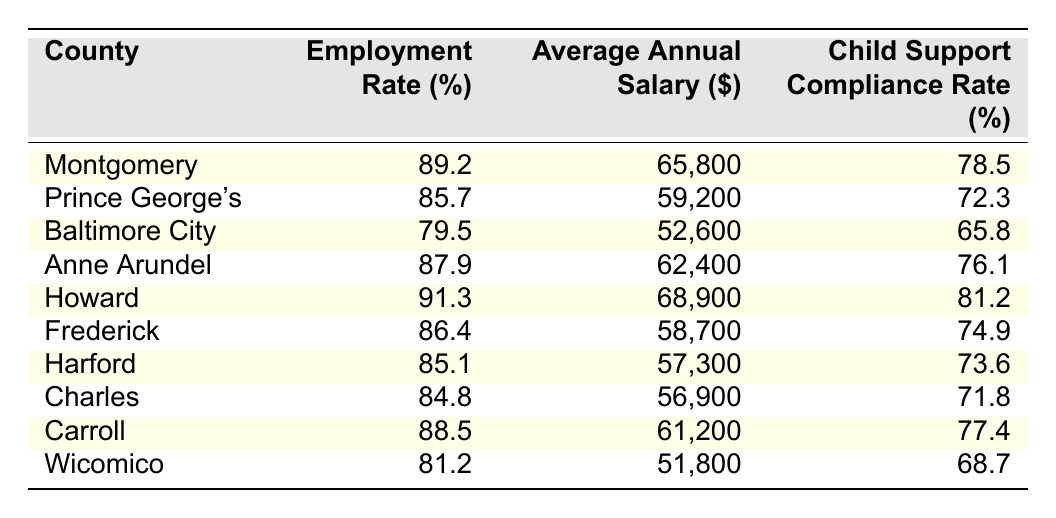What is the employment rate in Howard County? The table shows that the employment rate in Howard County is directly listed as 91.3%.
Answer: 91.3% Which county has the highest average annual salary? By examining the "Average Annual Salary" column, Howard County has the highest salary at $68,900.
Answer: Howard County What is the average employment rate of all the counties listed? The employment rates are 89.2, 85.7, 79.5, 87.9, 91.3, 86.4, 85.1, 84.8, 88.5, and 81.2. Adding these gives a total of 870.2, then dividing by 10 counties gives an average of 87.02%.
Answer: 87.02% Is the child support compliance rate in Baltimore City greater than the average for all counties? The child support compliance rate in Baltimore City is 65.8%, and calculating the average compliance from other counties, which sum to 76.4% and divide by 10 gives 76.4%. Since 65.8% is less than 76.4%, the answer is no.
Answer: No What is the difference in average salary between Montgomery County and Wicomico County? The average salary in Montgomery County is $65,800 and in Wicomico County is $51,800. The difference is $65,800 - $51,800, which equals $14,000.
Answer: $14,000 Which county has an employment rate lower than 85%? From the table, Baltimore City (79.5%) and Harford (85.1%) both have employment rates below 85%.
Answer: Baltimore City and Harford If you were to look for a county with both a high employment rate and high child support compliance, which would be the best option? Howard County has the highest employment rate at 91.3% and a child support compliance rate of 81.2%, making it the best option based on the data provided.
Answer: Howard County How many counties have a child support compliance rate above 75%? Counting the values in the "Child Support Compliance Rate" column, there are 5 counties (Montgomery, Anne Arundel, Howard, Carroll) with rates above 75%.
Answer: 5 counties What is the total child support compliance rate for all counties combined? By summing the child support compliance rates (78.5 + 72.3 + 65.8 + 76.1 + 81.2 + 74.9 + 73.6 + 71.8 + 77.4 + 68.7), the total is 790.5%. Dividing this by the 10 counties gives an average of 79.05%.
Answer: 79.05% Is the average salary higher in Prince George's County than in Frederick County? The average salary in Prince George's County is $59,200, while in Frederick County, it is $58,700. Therefore, $59,200 is greater than $58,700.
Answer: Yes 